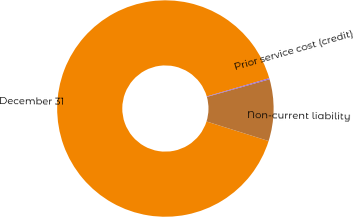<chart> <loc_0><loc_0><loc_500><loc_500><pie_chart><fcel>December 31<fcel>Non-current liability<fcel>Prior service cost (credit)<nl><fcel>90.62%<fcel>9.21%<fcel>0.17%<nl></chart> 